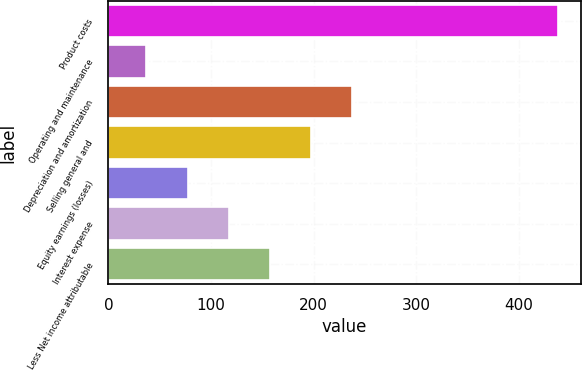Convert chart. <chart><loc_0><loc_0><loc_500><loc_500><bar_chart><fcel>Product costs<fcel>Operating and maintenance<fcel>Depreciation and amortization<fcel>Selling general and<fcel>Equity earnings (losses)<fcel>Interest expense<fcel>Less Net income attributable<nl><fcel>438<fcel>37<fcel>237.5<fcel>197.4<fcel>77.1<fcel>117.2<fcel>157.3<nl></chart> 